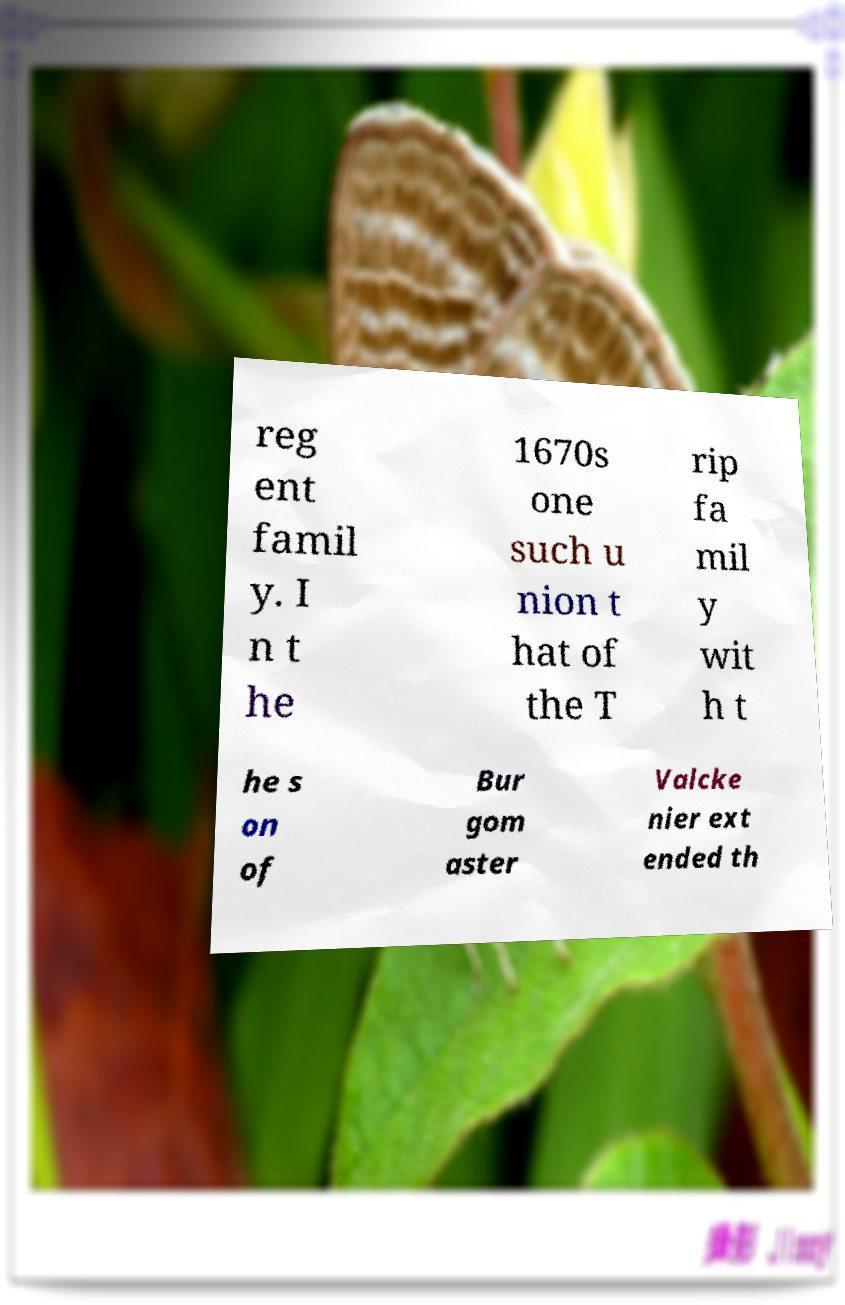Please identify and transcribe the text found in this image. reg ent famil y. I n t he 1670s one such u nion t hat of the T rip fa mil y wit h t he s on of Bur gom aster Valcke nier ext ended th 